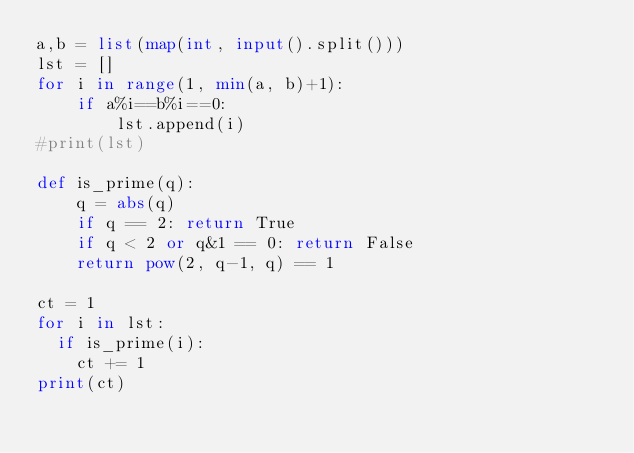Convert code to text. <code><loc_0><loc_0><loc_500><loc_500><_Python_>a,b = list(map(int, input().split()))
lst = []
for i in range(1, min(a, b)+1): 
    if a%i==b%i==0: 
        lst.append(i)
#print(lst)

def is_prime(q):
    q = abs(q)
    if q == 2: return True
    if q < 2 or q&1 == 0: return False
    return pow(2, q-1, q) == 1

ct = 1
for i in lst:
  if is_prime(i):
    ct += 1
print(ct)</code> 